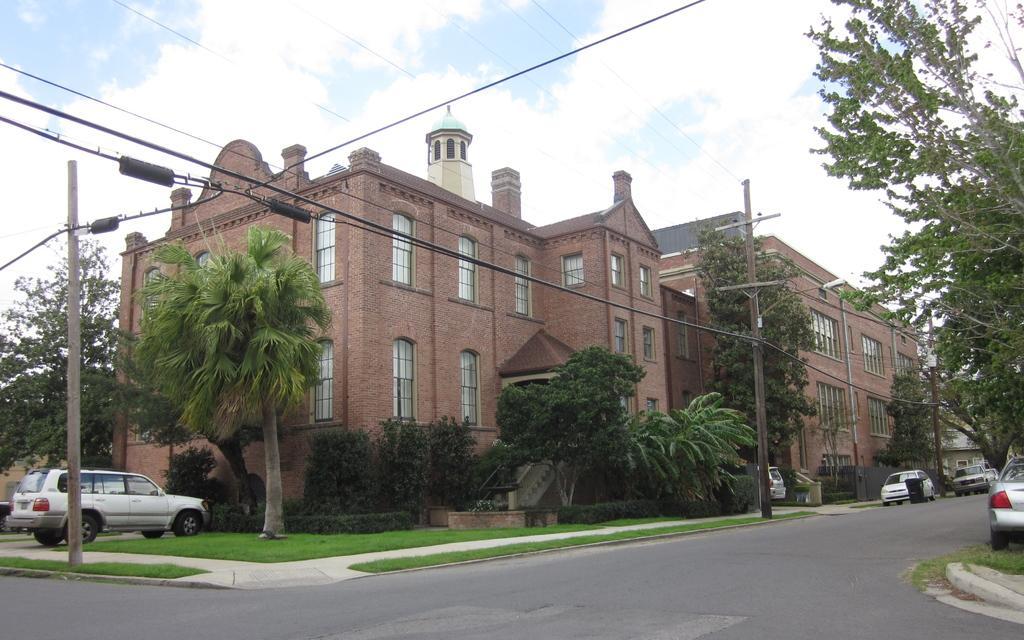Describe this image in one or two sentences. In this picture I can see many buildings. On the right I can see some cars were parked near to the dustbin and electric poles. On the left I can see another car which is parked near to the plants, grass and trees. At the top I can see the sky and clouds. 